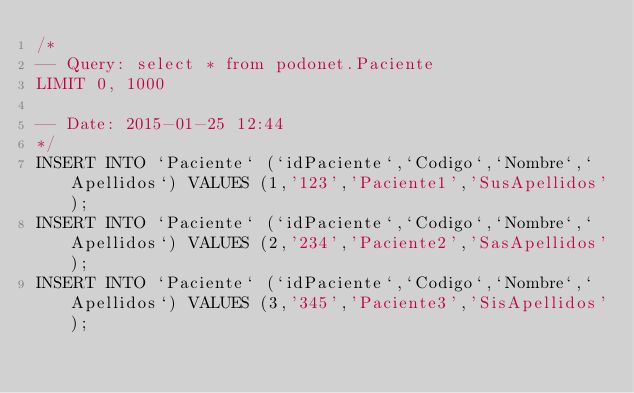<code> <loc_0><loc_0><loc_500><loc_500><_SQL_>/*
-- Query: select * from podonet.Paciente
LIMIT 0, 1000

-- Date: 2015-01-25 12:44
*/
INSERT INTO `Paciente` (`idPaciente`,`Codigo`,`Nombre`,`Apellidos`) VALUES (1,'123','Paciente1','SusApellidos');
INSERT INTO `Paciente` (`idPaciente`,`Codigo`,`Nombre`,`Apellidos`) VALUES (2,'234','Paciente2','SasApellidos');
INSERT INTO `Paciente` (`idPaciente`,`Codigo`,`Nombre`,`Apellidos`) VALUES (3,'345','Paciente3','SisApellidos');
</code> 